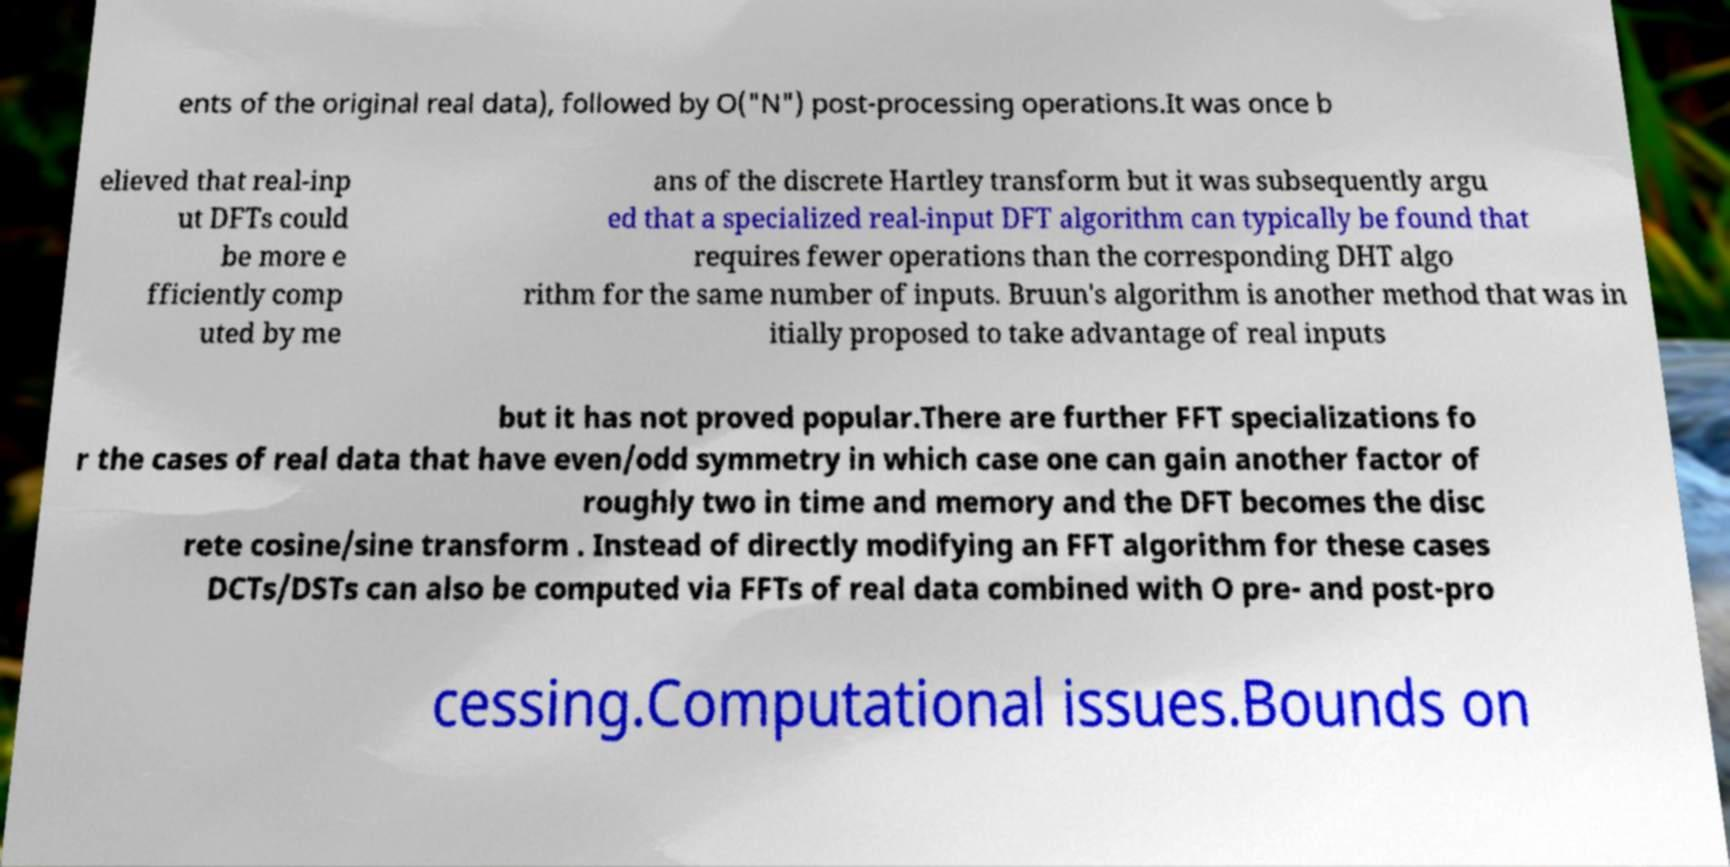Could you assist in decoding the text presented in this image and type it out clearly? ents of the original real data), followed by O("N") post-processing operations.It was once b elieved that real-inp ut DFTs could be more e fficiently comp uted by me ans of the discrete Hartley transform but it was subsequently argu ed that a specialized real-input DFT algorithm can typically be found that requires fewer operations than the corresponding DHT algo rithm for the same number of inputs. Bruun's algorithm is another method that was in itially proposed to take advantage of real inputs but it has not proved popular.There are further FFT specializations fo r the cases of real data that have even/odd symmetry in which case one can gain another factor of roughly two in time and memory and the DFT becomes the disc rete cosine/sine transform . Instead of directly modifying an FFT algorithm for these cases DCTs/DSTs can also be computed via FFTs of real data combined with O pre- and post-pro cessing.Computational issues.Bounds on 